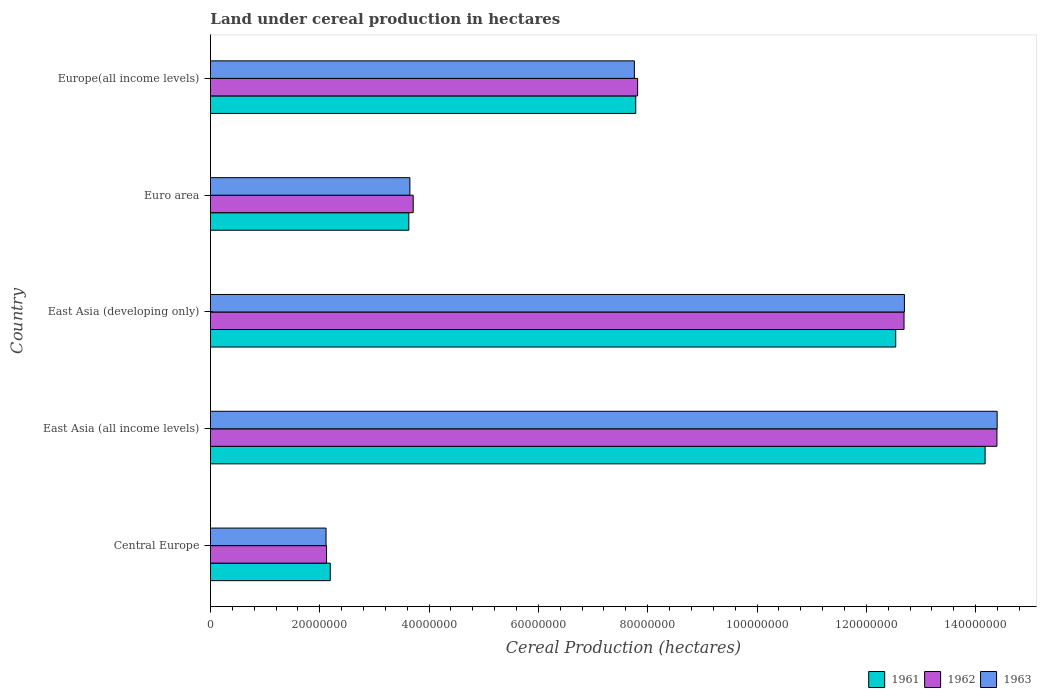How many different coloured bars are there?
Provide a succinct answer. 3. Are the number of bars per tick equal to the number of legend labels?
Your answer should be compact. Yes. How many bars are there on the 5th tick from the bottom?
Offer a terse response. 3. What is the label of the 5th group of bars from the top?
Provide a short and direct response. Central Europe. In how many cases, is the number of bars for a given country not equal to the number of legend labels?
Provide a short and direct response. 0. What is the land under cereal production in 1963 in East Asia (developing only)?
Keep it short and to the point. 1.27e+08. Across all countries, what is the maximum land under cereal production in 1962?
Your response must be concise. 1.44e+08. Across all countries, what is the minimum land under cereal production in 1962?
Ensure brevity in your answer.  2.12e+07. In which country was the land under cereal production in 1962 maximum?
Keep it short and to the point. East Asia (all income levels). In which country was the land under cereal production in 1961 minimum?
Provide a short and direct response. Central Europe. What is the total land under cereal production in 1963 in the graph?
Your answer should be very brief. 4.06e+08. What is the difference between the land under cereal production in 1961 in East Asia (developing only) and that in Europe(all income levels)?
Ensure brevity in your answer.  4.76e+07. What is the difference between the land under cereal production in 1961 in Europe(all income levels) and the land under cereal production in 1963 in Central Europe?
Keep it short and to the point. 5.67e+07. What is the average land under cereal production in 1961 per country?
Provide a short and direct response. 8.06e+07. What is the difference between the land under cereal production in 1961 and land under cereal production in 1962 in Central Europe?
Make the answer very short. 6.84e+05. In how many countries, is the land under cereal production in 1963 greater than 68000000 hectares?
Your response must be concise. 3. What is the ratio of the land under cereal production in 1963 in Euro area to that in Europe(all income levels)?
Provide a short and direct response. 0.47. Is the difference between the land under cereal production in 1961 in East Asia (developing only) and Euro area greater than the difference between the land under cereal production in 1962 in East Asia (developing only) and Euro area?
Keep it short and to the point. No. What is the difference between the highest and the second highest land under cereal production in 1962?
Offer a terse response. 1.70e+07. What is the difference between the highest and the lowest land under cereal production in 1963?
Your answer should be compact. 1.23e+08. In how many countries, is the land under cereal production in 1962 greater than the average land under cereal production in 1962 taken over all countries?
Provide a succinct answer. 2. What does the 2nd bar from the bottom in East Asia (developing only) represents?
Give a very brief answer. 1962. Is it the case that in every country, the sum of the land under cereal production in 1962 and land under cereal production in 1963 is greater than the land under cereal production in 1961?
Offer a terse response. Yes. What is the difference between two consecutive major ticks on the X-axis?
Make the answer very short. 2.00e+07. Are the values on the major ticks of X-axis written in scientific E-notation?
Your answer should be compact. No. Does the graph contain any zero values?
Make the answer very short. No. How many legend labels are there?
Your answer should be compact. 3. What is the title of the graph?
Give a very brief answer. Land under cereal production in hectares. Does "1994" appear as one of the legend labels in the graph?
Your response must be concise. No. What is the label or title of the X-axis?
Offer a terse response. Cereal Production (hectares). What is the Cereal Production (hectares) of 1961 in Central Europe?
Keep it short and to the point. 2.19e+07. What is the Cereal Production (hectares) in 1962 in Central Europe?
Offer a terse response. 2.12e+07. What is the Cereal Production (hectares) of 1963 in Central Europe?
Offer a very short reply. 2.11e+07. What is the Cereal Production (hectares) of 1961 in East Asia (all income levels)?
Make the answer very short. 1.42e+08. What is the Cereal Production (hectares) in 1962 in East Asia (all income levels)?
Give a very brief answer. 1.44e+08. What is the Cereal Production (hectares) in 1963 in East Asia (all income levels)?
Ensure brevity in your answer.  1.44e+08. What is the Cereal Production (hectares) of 1961 in East Asia (developing only)?
Give a very brief answer. 1.25e+08. What is the Cereal Production (hectares) of 1962 in East Asia (developing only)?
Make the answer very short. 1.27e+08. What is the Cereal Production (hectares) of 1963 in East Asia (developing only)?
Keep it short and to the point. 1.27e+08. What is the Cereal Production (hectares) in 1961 in Euro area?
Provide a succinct answer. 3.63e+07. What is the Cereal Production (hectares) of 1962 in Euro area?
Offer a terse response. 3.71e+07. What is the Cereal Production (hectares) of 1963 in Euro area?
Keep it short and to the point. 3.65e+07. What is the Cereal Production (hectares) of 1961 in Europe(all income levels)?
Your answer should be very brief. 7.78e+07. What is the Cereal Production (hectares) of 1962 in Europe(all income levels)?
Keep it short and to the point. 7.82e+07. What is the Cereal Production (hectares) in 1963 in Europe(all income levels)?
Make the answer very short. 7.76e+07. Across all countries, what is the maximum Cereal Production (hectares) in 1961?
Offer a very short reply. 1.42e+08. Across all countries, what is the maximum Cereal Production (hectares) of 1962?
Keep it short and to the point. 1.44e+08. Across all countries, what is the maximum Cereal Production (hectares) of 1963?
Your response must be concise. 1.44e+08. Across all countries, what is the minimum Cereal Production (hectares) in 1961?
Offer a very short reply. 2.19e+07. Across all countries, what is the minimum Cereal Production (hectares) of 1962?
Keep it short and to the point. 2.12e+07. Across all countries, what is the minimum Cereal Production (hectares) of 1963?
Your response must be concise. 2.11e+07. What is the total Cereal Production (hectares) in 1961 in the graph?
Provide a succinct answer. 4.03e+08. What is the total Cereal Production (hectares) of 1962 in the graph?
Your response must be concise. 4.07e+08. What is the total Cereal Production (hectares) of 1963 in the graph?
Your response must be concise. 4.06e+08. What is the difference between the Cereal Production (hectares) of 1961 in Central Europe and that in East Asia (all income levels)?
Provide a short and direct response. -1.20e+08. What is the difference between the Cereal Production (hectares) of 1962 in Central Europe and that in East Asia (all income levels)?
Ensure brevity in your answer.  -1.23e+08. What is the difference between the Cereal Production (hectares) in 1963 in Central Europe and that in East Asia (all income levels)?
Your response must be concise. -1.23e+08. What is the difference between the Cereal Production (hectares) of 1961 in Central Europe and that in East Asia (developing only)?
Keep it short and to the point. -1.03e+08. What is the difference between the Cereal Production (hectares) of 1962 in Central Europe and that in East Asia (developing only)?
Your answer should be very brief. -1.06e+08. What is the difference between the Cereal Production (hectares) of 1963 in Central Europe and that in East Asia (developing only)?
Your response must be concise. -1.06e+08. What is the difference between the Cereal Production (hectares) of 1961 in Central Europe and that in Euro area?
Your answer should be compact. -1.44e+07. What is the difference between the Cereal Production (hectares) of 1962 in Central Europe and that in Euro area?
Give a very brief answer. -1.59e+07. What is the difference between the Cereal Production (hectares) of 1963 in Central Europe and that in Euro area?
Your answer should be compact. -1.53e+07. What is the difference between the Cereal Production (hectares) of 1961 in Central Europe and that in Europe(all income levels)?
Keep it short and to the point. -5.59e+07. What is the difference between the Cereal Production (hectares) of 1962 in Central Europe and that in Europe(all income levels)?
Provide a short and direct response. -5.69e+07. What is the difference between the Cereal Production (hectares) of 1963 in Central Europe and that in Europe(all income levels)?
Offer a terse response. -5.64e+07. What is the difference between the Cereal Production (hectares) in 1961 in East Asia (all income levels) and that in East Asia (developing only)?
Provide a short and direct response. 1.64e+07. What is the difference between the Cereal Production (hectares) in 1962 in East Asia (all income levels) and that in East Asia (developing only)?
Offer a terse response. 1.70e+07. What is the difference between the Cereal Production (hectares) in 1963 in East Asia (all income levels) and that in East Asia (developing only)?
Keep it short and to the point. 1.70e+07. What is the difference between the Cereal Production (hectares) in 1961 in East Asia (all income levels) and that in Euro area?
Give a very brief answer. 1.05e+08. What is the difference between the Cereal Production (hectares) in 1962 in East Asia (all income levels) and that in Euro area?
Your answer should be very brief. 1.07e+08. What is the difference between the Cereal Production (hectares) in 1963 in East Asia (all income levels) and that in Euro area?
Your answer should be very brief. 1.07e+08. What is the difference between the Cereal Production (hectares) of 1961 in East Asia (all income levels) and that in Europe(all income levels)?
Provide a short and direct response. 6.39e+07. What is the difference between the Cereal Production (hectares) of 1962 in East Asia (all income levels) and that in Europe(all income levels)?
Ensure brevity in your answer.  6.57e+07. What is the difference between the Cereal Production (hectares) in 1963 in East Asia (all income levels) and that in Europe(all income levels)?
Offer a terse response. 6.64e+07. What is the difference between the Cereal Production (hectares) in 1961 in East Asia (developing only) and that in Euro area?
Ensure brevity in your answer.  8.91e+07. What is the difference between the Cereal Production (hectares) of 1962 in East Asia (developing only) and that in Euro area?
Offer a terse response. 8.98e+07. What is the difference between the Cereal Production (hectares) of 1963 in East Asia (developing only) and that in Euro area?
Ensure brevity in your answer.  9.05e+07. What is the difference between the Cereal Production (hectares) of 1961 in East Asia (developing only) and that in Europe(all income levels)?
Give a very brief answer. 4.76e+07. What is the difference between the Cereal Production (hectares) in 1962 in East Asia (developing only) and that in Europe(all income levels)?
Ensure brevity in your answer.  4.87e+07. What is the difference between the Cereal Production (hectares) of 1963 in East Asia (developing only) and that in Europe(all income levels)?
Offer a terse response. 4.94e+07. What is the difference between the Cereal Production (hectares) in 1961 in Euro area and that in Europe(all income levels)?
Offer a terse response. -4.15e+07. What is the difference between the Cereal Production (hectares) of 1962 in Euro area and that in Europe(all income levels)?
Offer a very short reply. -4.11e+07. What is the difference between the Cereal Production (hectares) in 1963 in Euro area and that in Europe(all income levels)?
Your answer should be very brief. -4.11e+07. What is the difference between the Cereal Production (hectares) of 1961 in Central Europe and the Cereal Production (hectares) of 1962 in East Asia (all income levels)?
Your answer should be compact. -1.22e+08. What is the difference between the Cereal Production (hectares) in 1961 in Central Europe and the Cereal Production (hectares) in 1963 in East Asia (all income levels)?
Ensure brevity in your answer.  -1.22e+08. What is the difference between the Cereal Production (hectares) in 1962 in Central Europe and the Cereal Production (hectares) in 1963 in East Asia (all income levels)?
Provide a succinct answer. -1.23e+08. What is the difference between the Cereal Production (hectares) of 1961 in Central Europe and the Cereal Production (hectares) of 1962 in East Asia (developing only)?
Keep it short and to the point. -1.05e+08. What is the difference between the Cereal Production (hectares) of 1961 in Central Europe and the Cereal Production (hectares) of 1963 in East Asia (developing only)?
Your answer should be very brief. -1.05e+08. What is the difference between the Cereal Production (hectares) of 1962 in Central Europe and the Cereal Production (hectares) of 1963 in East Asia (developing only)?
Offer a terse response. -1.06e+08. What is the difference between the Cereal Production (hectares) of 1961 in Central Europe and the Cereal Production (hectares) of 1962 in Euro area?
Keep it short and to the point. -1.52e+07. What is the difference between the Cereal Production (hectares) in 1961 in Central Europe and the Cereal Production (hectares) in 1963 in Euro area?
Your answer should be very brief. -1.46e+07. What is the difference between the Cereal Production (hectares) in 1962 in Central Europe and the Cereal Production (hectares) in 1963 in Euro area?
Your answer should be compact. -1.53e+07. What is the difference between the Cereal Production (hectares) in 1961 in Central Europe and the Cereal Production (hectares) in 1962 in Europe(all income levels)?
Your answer should be compact. -5.62e+07. What is the difference between the Cereal Production (hectares) in 1961 in Central Europe and the Cereal Production (hectares) in 1963 in Europe(all income levels)?
Your answer should be very brief. -5.56e+07. What is the difference between the Cereal Production (hectares) in 1962 in Central Europe and the Cereal Production (hectares) in 1963 in Europe(all income levels)?
Give a very brief answer. -5.63e+07. What is the difference between the Cereal Production (hectares) in 1961 in East Asia (all income levels) and the Cereal Production (hectares) in 1962 in East Asia (developing only)?
Provide a short and direct response. 1.48e+07. What is the difference between the Cereal Production (hectares) of 1961 in East Asia (all income levels) and the Cereal Production (hectares) of 1963 in East Asia (developing only)?
Offer a very short reply. 1.48e+07. What is the difference between the Cereal Production (hectares) of 1962 in East Asia (all income levels) and the Cereal Production (hectares) of 1963 in East Asia (developing only)?
Give a very brief answer. 1.69e+07. What is the difference between the Cereal Production (hectares) in 1961 in East Asia (all income levels) and the Cereal Production (hectares) in 1962 in Euro area?
Provide a succinct answer. 1.05e+08. What is the difference between the Cereal Production (hectares) in 1961 in East Asia (all income levels) and the Cereal Production (hectares) in 1963 in Euro area?
Your answer should be compact. 1.05e+08. What is the difference between the Cereal Production (hectares) of 1962 in East Asia (all income levels) and the Cereal Production (hectares) of 1963 in Euro area?
Give a very brief answer. 1.07e+08. What is the difference between the Cereal Production (hectares) of 1961 in East Asia (all income levels) and the Cereal Production (hectares) of 1962 in Europe(all income levels)?
Provide a succinct answer. 6.36e+07. What is the difference between the Cereal Production (hectares) of 1961 in East Asia (all income levels) and the Cereal Production (hectares) of 1963 in Europe(all income levels)?
Your response must be concise. 6.42e+07. What is the difference between the Cereal Production (hectares) in 1962 in East Asia (all income levels) and the Cereal Production (hectares) in 1963 in Europe(all income levels)?
Your answer should be compact. 6.63e+07. What is the difference between the Cereal Production (hectares) of 1961 in East Asia (developing only) and the Cereal Production (hectares) of 1962 in Euro area?
Offer a very short reply. 8.83e+07. What is the difference between the Cereal Production (hectares) of 1961 in East Asia (developing only) and the Cereal Production (hectares) of 1963 in Euro area?
Provide a short and direct response. 8.89e+07. What is the difference between the Cereal Production (hectares) in 1962 in East Asia (developing only) and the Cereal Production (hectares) in 1963 in Euro area?
Keep it short and to the point. 9.04e+07. What is the difference between the Cereal Production (hectares) of 1961 in East Asia (developing only) and the Cereal Production (hectares) of 1962 in Europe(all income levels)?
Offer a terse response. 4.72e+07. What is the difference between the Cereal Production (hectares) in 1961 in East Asia (developing only) and the Cereal Production (hectares) in 1963 in Europe(all income levels)?
Your response must be concise. 4.78e+07. What is the difference between the Cereal Production (hectares) in 1962 in East Asia (developing only) and the Cereal Production (hectares) in 1963 in Europe(all income levels)?
Your answer should be very brief. 4.93e+07. What is the difference between the Cereal Production (hectares) of 1961 in Euro area and the Cereal Production (hectares) of 1962 in Europe(all income levels)?
Make the answer very short. -4.19e+07. What is the difference between the Cereal Production (hectares) of 1961 in Euro area and the Cereal Production (hectares) of 1963 in Europe(all income levels)?
Provide a succinct answer. -4.13e+07. What is the difference between the Cereal Production (hectares) of 1962 in Euro area and the Cereal Production (hectares) of 1963 in Europe(all income levels)?
Your answer should be compact. -4.05e+07. What is the average Cereal Production (hectares) of 1961 per country?
Give a very brief answer. 8.06e+07. What is the average Cereal Production (hectares) of 1962 per country?
Give a very brief answer. 8.15e+07. What is the average Cereal Production (hectares) of 1963 per country?
Offer a very short reply. 8.12e+07. What is the difference between the Cereal Production (hectares) in 1961 and Cereal Production (hectares) in 1962 in Central Europe?
Give a very brief answer. 6.84e+05. What is the difference between the Cereal Production (hectares) in 1961 and Cereal Production (hectares) in 1963 in Central Europe?
Your answer should be very brief. 7.75e+05. What is the difference between the Cereal Production (hectares) in 1962 and Cereal Production (hectares) in 1963 in Central Europe?
Make the answer very short. 9.14e+04. What is the difference between the Cereal Production (hectares) of 1961 and Cereal Production (hectares) of 1962 in East Asia (all income levels)?
Ensure brevity in your answer.  -2.17e+06. What is the difference between the Cereal Production (hectares) of 1961 and Cereal Production (hectares) of 1963 in East Asia (all income levels)?
Ensure brevity in your answer.  -2.21e+06. What is the difference between the Cereal Production (hectares) of 1962 and Cereal Production (hectares) of 1963 in East Asia (all income levels)?
Your answer should be compact. -3.63e+04. What is the difference between the Cereal Production (hectares) of 1961 and Cereal Production (hectares) of 1962 in East Asia (developing only)?
Ensure brevity in your answer.  -1.52e+06. What is the difference between the Cereal Production (hectares) in 1961 and Cereal Production (hectares) in 1963 in East Asia (developing only)?
Your answer should be compact. -1.59e+06. What is the difference between the Cereal Production (hectares) of 1962 and Cereal Production (hectares) of 1963 in East Asia (developing only)?
Provide a succinct answer. -7.11e+04. What is the difference between the Cereal Production (hectares) in 1961 and Cereal Production (hectares) in 1962 in Euro area?
Offer a terse response. -8.01e+05. What is the difference between the Cereal Production (hectares) of 1961 and Cereal Production (hectares) of 1963 in Euro area?
Provide a short and direct response. -1.95e+05. What is the difference between the Cereal Production (hectares) of 1962 and Cereal Production (hectares) of 1963 in Euro area?
Keep it short and to the point. 6.06e+05. What is the difference between the Cereal Production (hectares) of 1961 and Cereal Production (hectares) of 1962 in Europe(all income levels)?
Ensure brevity in your answer.  -3.44e+05. What is the difference between the Cereal Production (hectares) of 1961 and Cereal Production (hectares) of 1963 in Europe(all income levels)?
Make the answer very short. 2.50e+05. What is the difference between the Cereal Production (hectares) in 1962 and Cereal Production (hectares) in 1963 in Europe(all income levels)?
Provide a short and direct response. 5.94e+05. What is the ratio of the Cereal Production (hectares) in 1961 in Central Europe to that in East Asia (all income levels)?
Keep it short and to the point. 0.15. What is the ratio of the Cereal Production (hectares) in 1962 in Central Europe to that in East Asia (all income levels)?
Ensure brevity in your answer.  0.15. What is the ratio of the Cereal Production (hectares) of 1963 in Central Europe to that in East Asia (all income levels)?
Give a very brief answer. 0.15. What is the ratio of the Cereal Production (hectares) in 1961 in Central Europe to that in East Asia (developing only)?
Offer a very short reply. 0.17. What is the ratio of the Cereal Production (hectares) of 1962 in Central Europe to that in East Asia (developing only)?
Your answer should be compact. 0.17. What is the ratio of the Cereal Production (hectares) in 1963 in Central Europe to that in East Asia (developing only)?
Offer a very short reply. 0.17. What is the ratio of the Cereal Production (hectares) of 1961 in Central Europe to that in Euro area?
Offer a very short reply. 0.6. What is the ratio of the Cereal Production (hectares) of 1962 in Central Europe to that in Euro area?
Keep it short and to the point. 0.57. What is the ratio of the Cereal Production (hectares) of 1963 in Central Europe to that in Euro area?
Keep it short and to the point. 0.58. What is the ratio of the Cereal Production (hectares) of 1961 in Central Europe to that in Europe(all income levels)?
Your answer should be very brief. 0.28. What is the ratio of the Cereal Production (hectares) of 1962 in Central Europe to that in Europe(all income levels)?
Your answer should be very brief. 0.27. What is the ratio of the Cereal Production (hectares) in 1963 in Central Europe to that in Europe(all income levels)?
Your response must be concise. 0.27. What is the ratio of the Cereal Production (hectares) of 1961 in East Asia (all income levels) to that in East Asia (developing only)?
Keep it short and to the point. 1.13. What is the ratio of the Cereal Production (hectares) of 1962 in East Asia (all income levels) to that in East Asia (developing only)?
Offer a very short reply. 1.13. What is the ratio of the Cereal Production (hectares) of 1963 in East Asia (all income levels) to that in East Asia (developing only)?
Ensure brevity in your answer.  1.13. What is the ratio of the Cereal Production (hectares) of 1961 in East Asia (all income levels) to that in Euro area?
Your response must be concise. 3.91. What is the ratio of the Cereal Production (hectares) in 1962 in East Asia (all income levels) to that in Euro area?
Your answer should be compact. 3.88. What is the ratio of the Cereal Production (hectares) in 1963 in East Asia (all income levels) to that in Euro area?
Give a very brief answer. 3.94. What is the ratio of the Cereal Production (hectares) in 1961 in East Asia (all income levels) to that in Europe(all income levels)?
Make the answer very short. 1.82. What is the ratio of the Cereal Production (hectares) in 1962 in East Asia (all income levels) to that in Europe(all income levels)?
Offer a terse response. 1.84. What is the ratio of the Cereal Production (hectares) of 1963 in East Asia (all income levels) to that in Europe(all income levels)?
Keep it short and to the point. 1.86. What is the ratio of the Cereal Production (hectares) in 1961 in East Asia (developing only) to that in Euro area?
Keep it short and to the point. 3.45. What is the ratio of the Cereal Production (hectares) in 1962 in East Asia (developing only) to that in Euro area?
Keep it short and to the point. 3.42. What is the ratio of the Cereal Production (hectares) of 1963 in East Asia (developing only) to that in Euro area?
Your answer should be compact. 3.48. What is the ratio of the Cereal Production (hectares) in 1961 in East Asia (developing only) to that in Europe(all income levels)?
Offer a terse response. 1.61. What is the ratio of the Cereal Production (hectares) of 1962 in East Asia (developing only) to that in Europe(all income levels)?
Your answer should be very brief. 1.62. What is the ratio of the Cereal Production (hectares) of 1963 in East Asia (developing only) to that in Europe(all income levels)?
Provide a short and direct response. 1.64. What is the ratio of the Cereal Production (hectares) of 1961 in Euro area to that in Europe(all income levels)?
Your answer should be very brief. 0.47. What is the ratio of the Cereal Production (hectares) of 1962 in Euro area to that in Europe(all income levels)?
Offer a terse response. 0.47. What is the ratio of the Cereal Production (hectares) of 1963 in Euro area to that in Europe(all income levels)?
Provide a succinct answer. 0.47. What is the difference between the highest and the second highest Cereal Production (hectares) of 1961?
Offer a very short reply. 1.64e+07. What is the difference between the highest and the second highest Cereal Production (hectares) of 1962?
Make the answer very short. 1.70e+07. What is the difference between the highest and the second highest Cereal Production (hectares) in 1963?
Your response must be concise. 1.70e+07. What is the difference between the highest and the lowest Cereal Production (hectares) in 1961?
Keep it short and to the point. 1.20e+08. What is the difference between the highest and the lowest Cereal Production (hectares) in 1962?
Your response must be concise. 1.23e+08. What is the difference between the highest and the lowest Cereal Production (hectares) in 1963?
Give a very brief answer. 1.23e+08. 